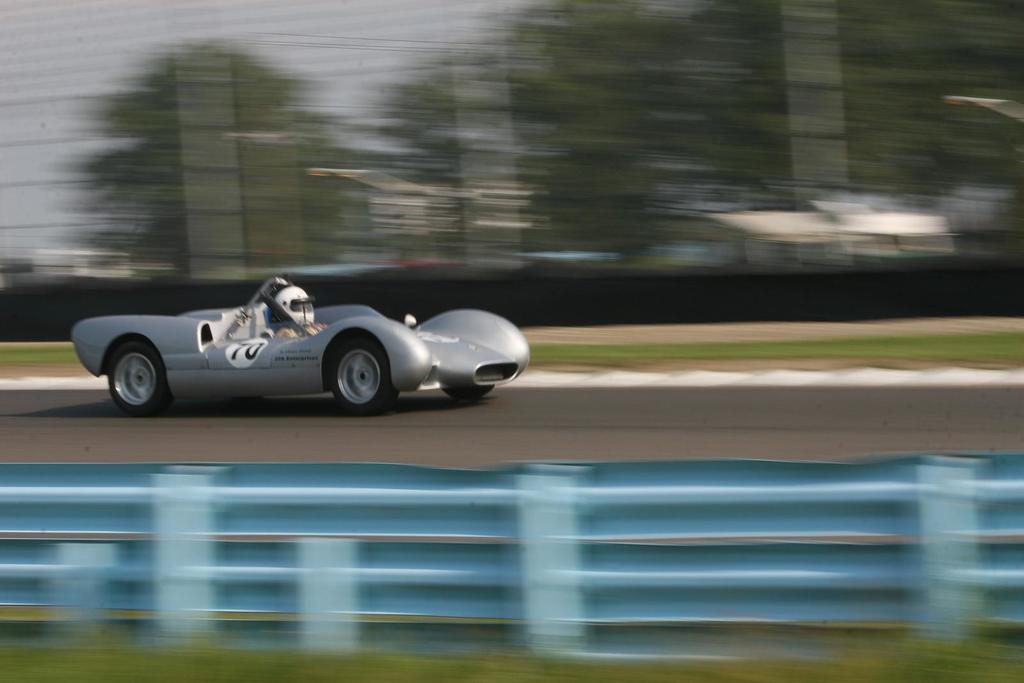In one or two sentences, can you explain what this image depicts? In this image we can see a person wearing the helmet and sitting in the race car. We can also see the road, trees and also the sky. The image is blurred. At the bottom we can see the grass. 